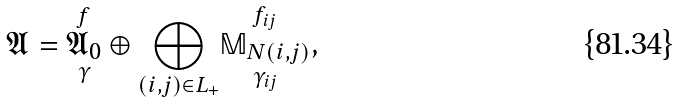<formula> <loc_0><loc_0><loc_500><loc_500>\mathfrak { A } = \underset { \gamma } { \overset { f } { \mathfrak { A } _ { 0 } } } \oplus \underset { ( i , j ) \in L _ { + } } { \bigoplus } \underset { \gamma _ { i j } } { \overset { f _ { i j } } { \mathbb { M } _ { N ( i , j ) } } } ,</formula> 